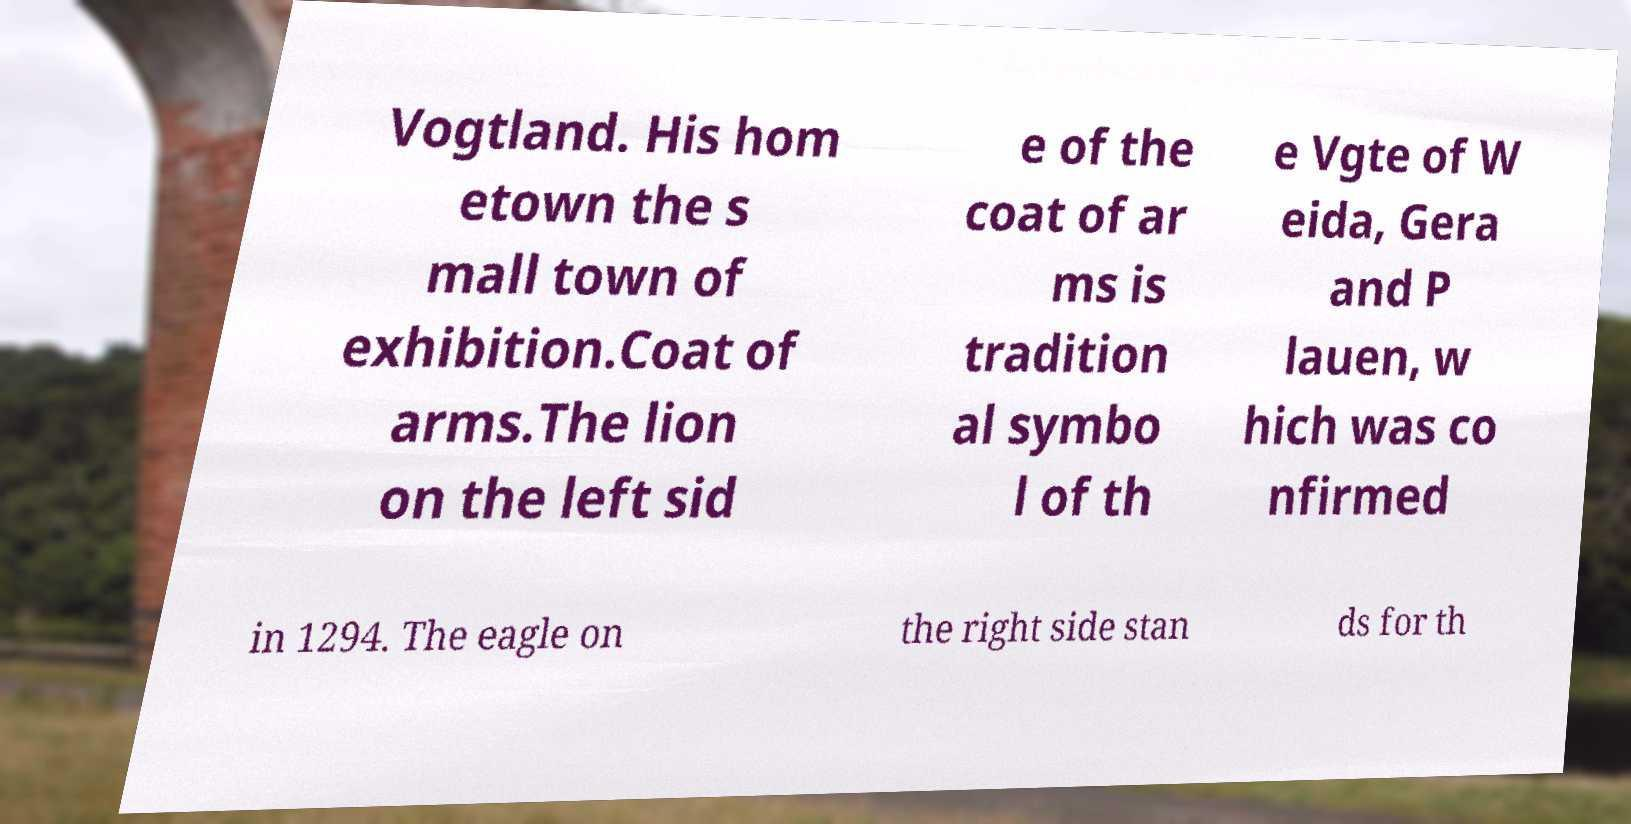What messages or text are displayed in this image? I need them in a readable, typed format. Vogtland. His hom etown the s mall town of exhibition.Coat of arms.The lion on the left sid e of the coat of ar ms is tradition al symbo l of th e Vgte of W eida, Gera and P lauen, w hich was co nfirmed in 1294. The eagle on the right side stan ds for th 